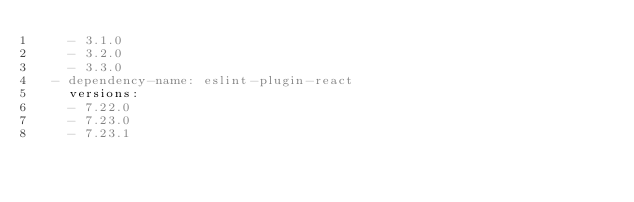<code> <loc_0><loc_0><loc_500><loc_500><_YAML_>    - 3.1.0
    - 3.2.0
    - 3.3.0
  - dependency-name: eslint-plugin-react
    versions:
    - 7.22.0
    - 7.23.0
    - 7.23.1
</code> 